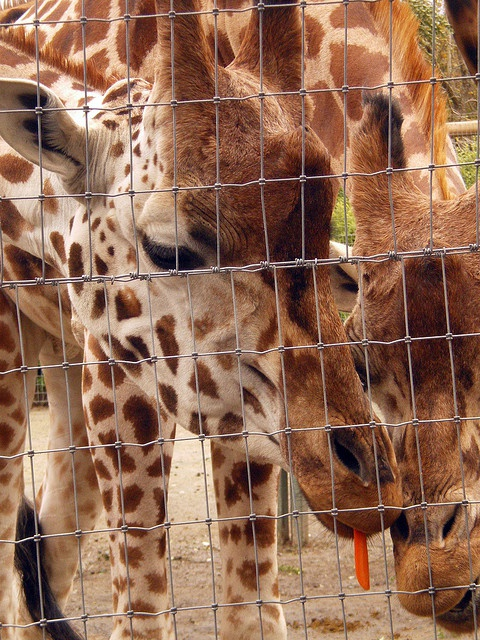Describe the objects in this image and their specific colors. I can see giraffe in lavender, maroon, gray, tan, and black tones, giraffe in lavender, maroon, brown, and tan tones, and carrot in lavender, brown, red, and maroon tones in this image. 